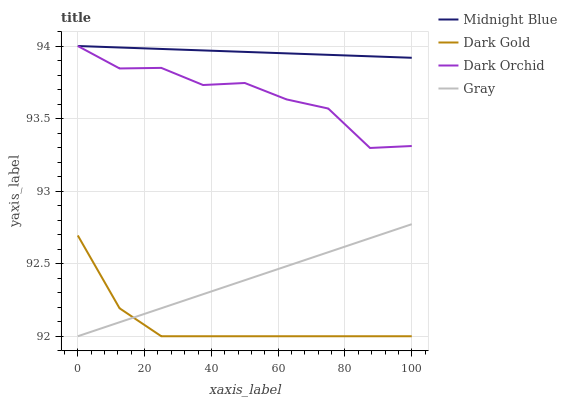Does Dark Orchid have the minimum area under the curve?
Answer yes or no. No. Does Dark Orchid have the maximum area under the curve?
Answer yes or no. No. Is Dark Orchid the smoothest?
Answer yes or no. No. Is Midnight Blue the roughest?
Answer yes or no. No. Does Dark Orchid have the lowest value?
Answer yes or no. No. Does Dark Gold have the highest value?
Answer yes or no. No. Is Gray less than Dark Orchid?
Answer yes or no. Yes. Is Midnight Blue greater than Gray?
Answer yes or no. Yes. Does Gray intersect Dark Orchid?
Answer yes or no. No. 